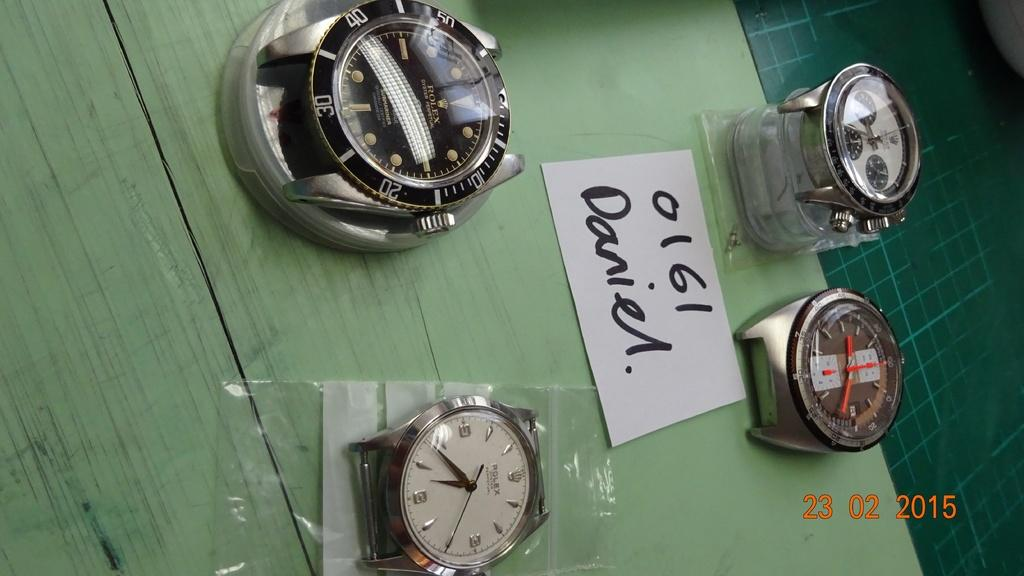What objects are present in the image? There are watches and a paper in the image. Where are the watches and paper located? The watches and paper are placed on a table. What might the paper be used for? The paper could be used for writing, drawing, or taking notes. Can you see an airplane flying in the image? No, there is no airplane visible in the image. Are there any jewels or sparkling objects in the image? No, there are no jewels or sparkling objects mentioned in the provided facts. 